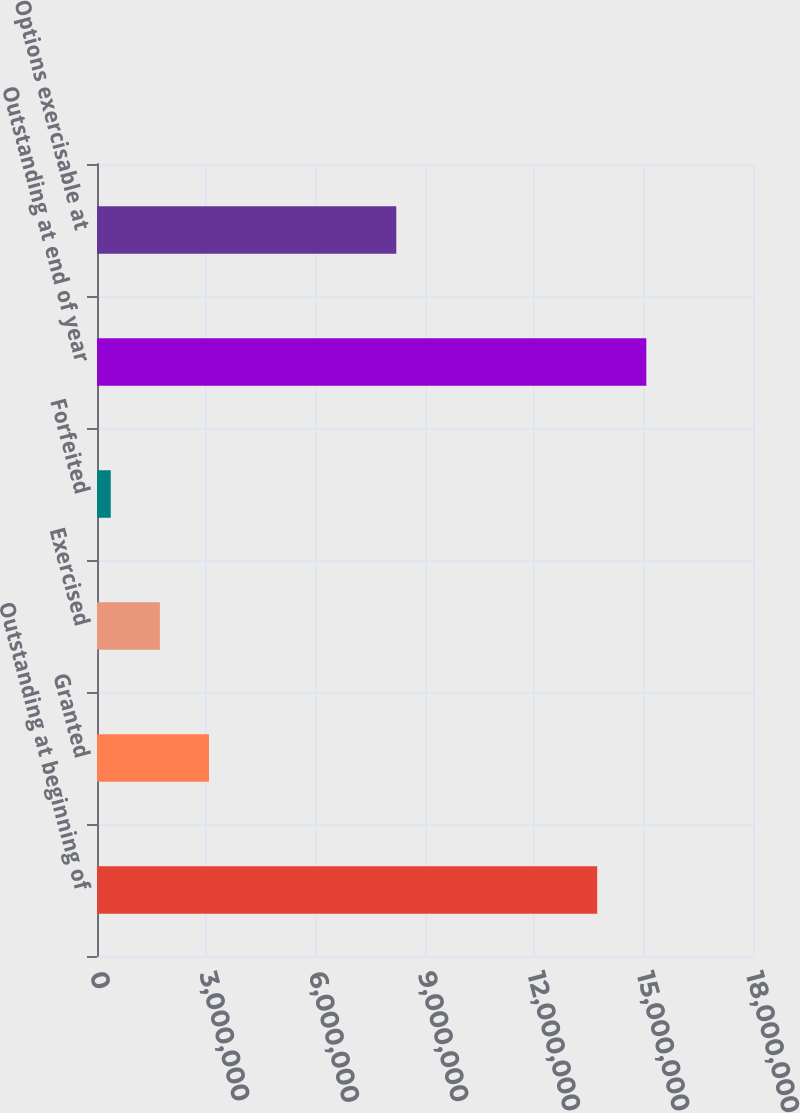<chart> <loc_0><loc_0><loc_500><loc_500><bar_chart><fcel>Outstanding at beginning of<fcel>Granted<fcel>Exercised<fcel>Forfeited<fcel>Outstanding at end of year<fcel>Options exercisable at<nl><fcel>1.37251e+07<fcel>3.07302e+06<fcel>1.72526e+06<fcel>377499<fcel>1.50729e+07<fcel>8.21221e+06<nl></chart> 